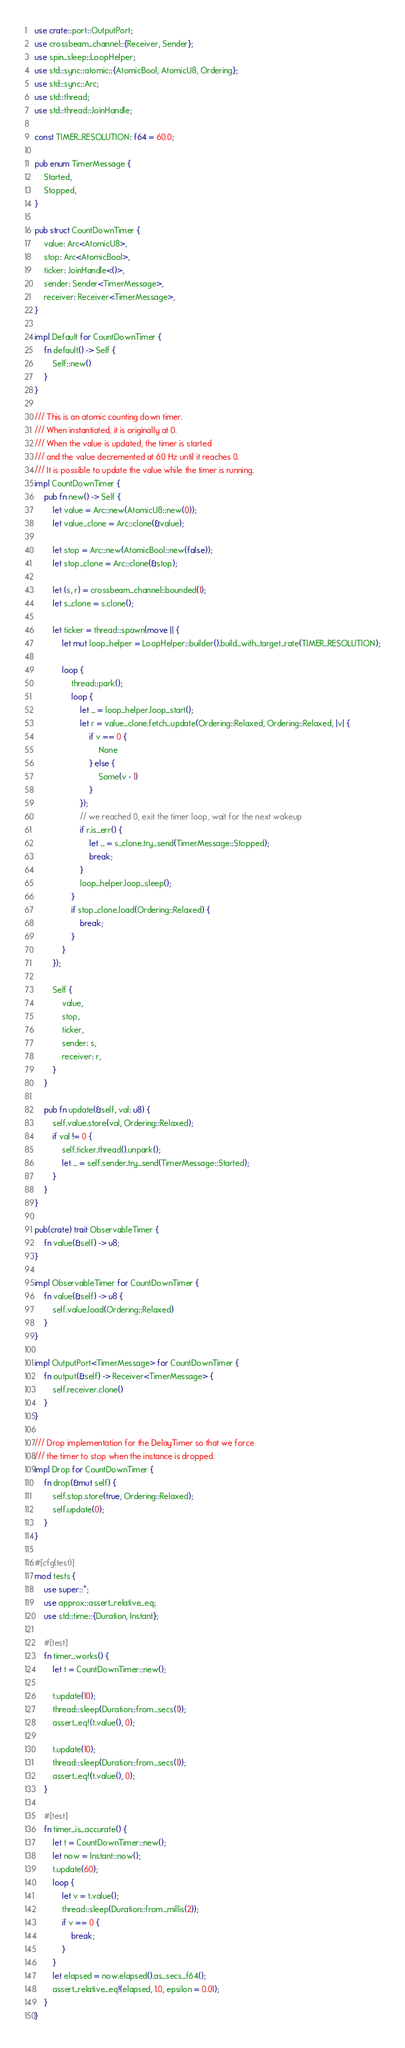Convert code to text. <code><loc_0><loc_0><loc_500><loc_500><_Rust_>use crate::port::OutputPort;
use crossbeam_channel::{Receiver, Sender};
use spin_sleep::LoopHelper;
use std::sync::atomic::{AtomicBool, AtomicU8, Ordering};
use std::sync::Arc;
use std::thread;
use std::thread::JoinHandle;

const TIMER_RESOLUTION: f64 = 60.0;

pub enum TimerMessage {
    Started,
    Stopped,
}

pub struct CountDownTimer {
    value: Arc<AtomicU8>,
    stop: Arc<AtomicBool>,
    ticker: JoinHandle<()>,
    sender: Sender<TimerMessage>,
    receiver: Receiver<TimerMessage>,
}

impl Default for CountDownTimer {
    fn default() -> Self {
        Self::new()
    }
}

/// This is an atomic counting down timer.
/// When instantiated, it is originally at 0.
/// When the value is updated, the timer is started
/// and the value decremented at 60 Hz until it reaches 0.
/// It is possible to update the value while the timer is running.
impl CountDownTimer {
    pub fn new() -> Self {
        let value = Arc::new(AtomicU8::new(0));
        let value_clone = Arc::clone(&value);

        let stop = Arc::new(AtomicBool::new(false));
        let stop_clone = Arc::clone(&stop);

        let (s, r) = crossbeam_channel::bounded(1);
        let s_clone = s.clone();

        let ticker = thread::spawn(move || {
            let mut loop_helper = LoopHelper::builder().build_with_target_rate(TIMER_RESOLUTION);

            loop {
                thread::park();
                loop {
                    let _ = loop_helper.loop_start();
                    let r = value_clone.fetch_update(Ordering::Relaxed, Ordering::Relaxed, |v| {
                        if v == 0 {
                            None
                        } else {
                            Some(v - 1)
                        }
                    });
                    // we reached 0, exit the timer loop, wait for the next wakeup
                    if r.is_err() {
                        let _ = s_clone.try_send(TimerMessage::Stopped);
                        break;
                    }
                    loop_helper.loop_sleep();
                }
                if stop_clone.load(Ordering::Relaxed) {
                    break;
                }
            }
        });

        Self {
            value,
            stop,
            ticker,
            sender: s,
            receiver: r,
        }
    }

    pub fn update(&self, val: u8) {
        self.value.store(val, Ordering::Relaxed);
        if val != 0 {
            self.ticker.thread().unpark();
            let _ = self.sender.try_send(TimerMessage::Started);
        }
    }
}

pub(crate) trait ObservableTimer {
    fn value(&self) -> u8;
}

impl ObservableTimer for CountDownTimer {
    fn value(&self) -> u8 {
        self.value.load(Ordering::Relaxed)
    }
}

impl OutputPort<TimerMessage> for CountDownTimer {
    fn output(&self) -> Receiver<TimerMessage> {
        self.receiver.clone()
    }
}

/// Drop implementation for the DelayTimer so that we force
/// the timer to stop when the instance is dropped.
impl Drop for CountDownTimer {
    fn drop(&mut self) {
        self.stop.store(true, Ordering::Relaxed);
        self.update(0);
    }
}

#[cfg(test)]
mod tests {
    use super::*;
    use approx::assert_relative_eq;
    use std::time::{Duration, Instant};

    #[test]
    fn timer_works() {
        let t = CountDownTimer::new();

        t.update(10);
        thread::sleep(Duration::from_secs(1));
        assert_eq!(t.value(), 0);

        t.update(10);
        thread::sleep(Duration::from_secs(1));
        assert_eq!(t.value(), 0);
    }

    #[test]
    fn timer_is_accurate() {
        let t = CountDownTimer::new();
        let now = Instant::now();
        t.update(60);
        loop {
            let v = t.value();
            thread::sleep(Duration::from_millis(2));
            if v == 0 {
                break;
            }
        }
        let elapsed = now.elapsed().as_secs_f64();
        assert_relative_eq!(elapsed, 1.0, epsilon = 0.01);
    }
}
</code> 